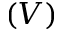Convert formula to latex. <formula><loc_0><loc_0><loc_500><loc_500>( V )</formula> 